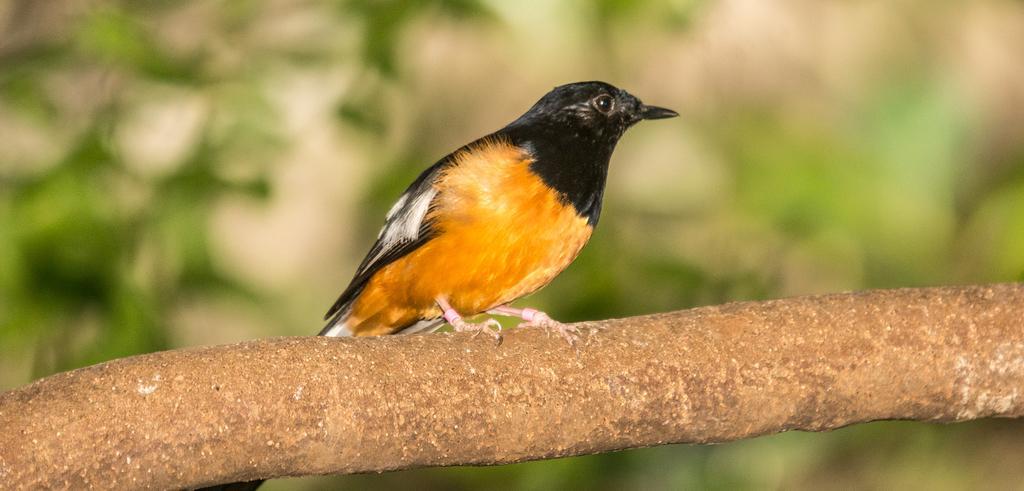Can you describe this image briefly? In this image we can see one bird on the surface which looks like a tree stem, it looks like some green leaves in the background and the background is blurred. 